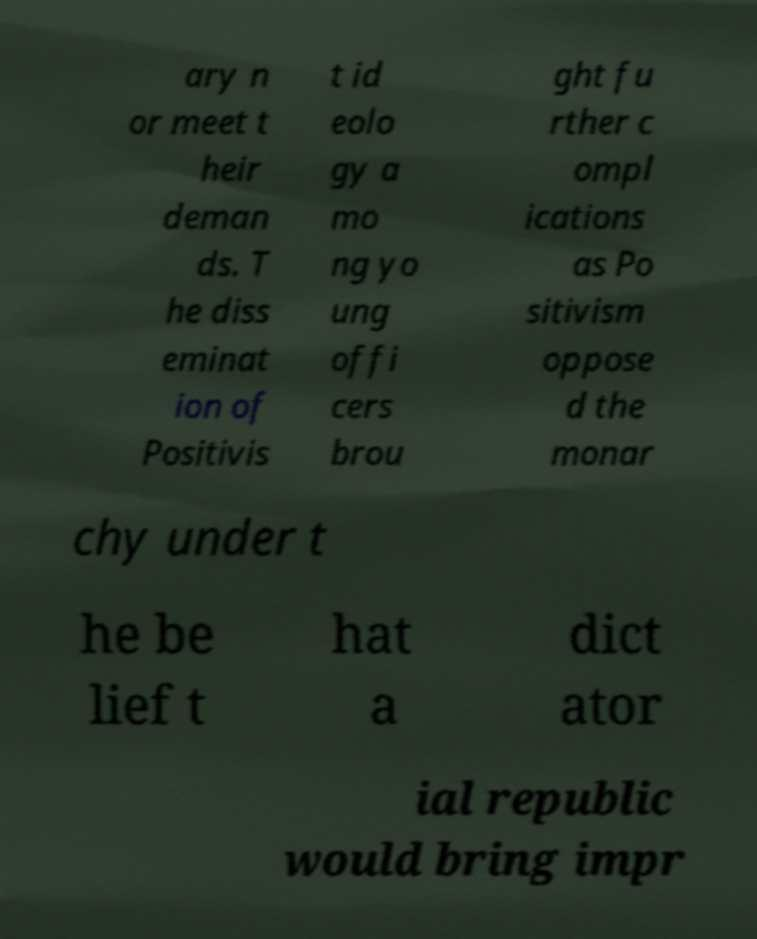For documentation purposes, I need the text within this image transcribed. Could you provide that? ary n or meet t heir deman ds. T he diss eminat ion of Positivis t id eolo gy a mo ng yo ung offi cers brou ght fu rther c ompl ications as Po sitivism oppose d the monar chy under t he be lief t hat a dict ator ial republic would bring impr 